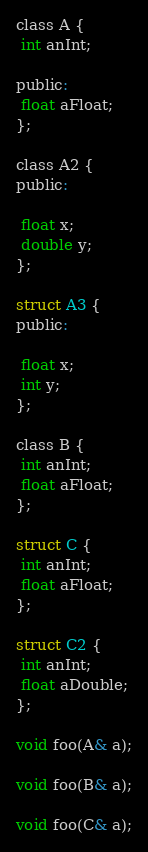Convert code to text. <code><loc_0><loc_0><loc_500><loc_500><_C_>class A {
 int anInt;

public: 
 float aFloat;
};

class A2 {
public: 

 float x;
 double y;
};

struct A3 {
public: 

 float x;
 int y;
};

class B {
 int anInt;
 float aFloat;
};

struct C {
 int anInt;
 float aFloat;
};

struct C2 {
 int anInt;
 float aDouble;
};

void foo(A& a);

void foo(B& a);

void foo(C& a);</code> 